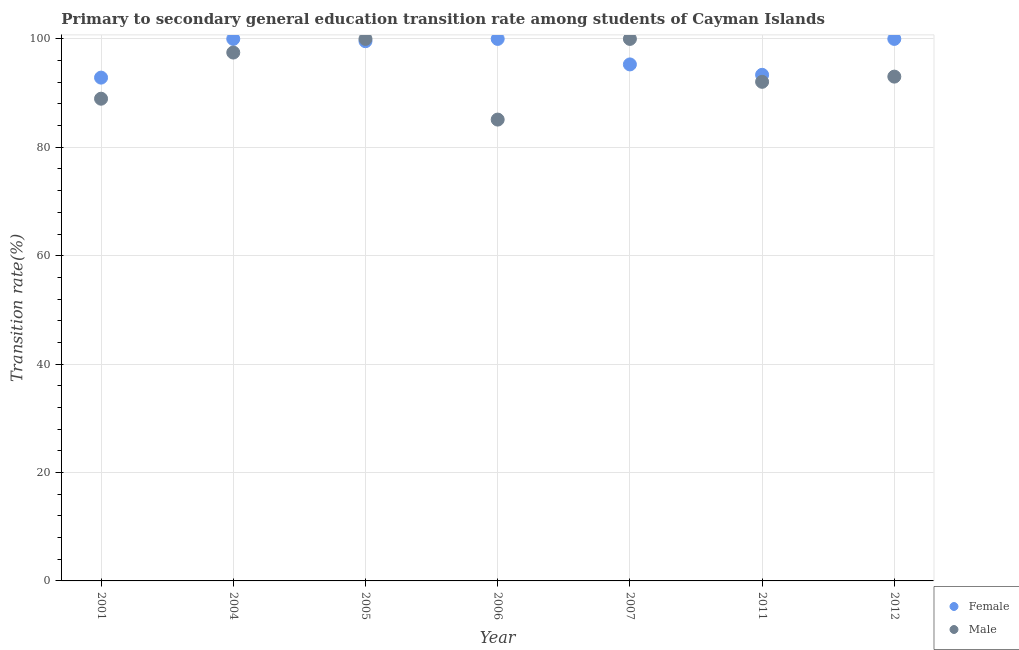What is the transition rate among male students in 2001?
Give a very brief answer. 88.97. Across all years, what is the minimum transition rate among male students?
Offer a very short reply. 85.12. In which year was the transition rate among male students maximum?
Provide a succinct answer. 2005. What is the total transition rate among female students in the graph?
Ensure brevity in your answer.  681.1. What is the difference between the transition rate among female students in 2001 and that in 2007?
Your response must be concise. -2.44. What is the difference between the transition rate among female students in 2006 and the transition rate among male students in 2004?
Make the answer very short. 2.52. What is the average transition rate among female students per year?
Offer a terse response. 97.3. In the year 2006, what is the difference between the transition rate among male students and transition rate among female students?
Keep it short and to the point. -14.88. In how many years, is the transition rate among male students greater than 84 %?
Your response must be concise. 7. What is the ratio of the transition rate among male students in 2006 to that in 2012?
Your response must be concise. 0.91. What is the difference between the highest and the second highest transition rate among male students?
Your response must be concise. 0. What is the difference between the highest and the lowest transition rate among male students?
Your answer should be compact. 14.88. In how many years, is the transition rate among female students greater than the average transition rate among female students taken over all years?
Your answer should be very brief. 4. Does the transition rate among male students monotonically increase over the years?
Provide a succinct answer. No. How many dotlines are there?
Your answer should be very brief. 2. How many years are there in the graph?
Your response must be concise. 7. Are the values on the major ticks of Y-axis written in scientific E-notation?
Make the answer very short. No. Does the graph contain any zero values?
Make the answer very short. No. Does the graph contain grids?
Provide a succinct answer. Yes. Where does the legend appear in the graph?
Give a very brief answer. Bottom right. What is the title of the graph?
Ensure brevity in your answer.  Primary to secondary general education transition rate among students of Cayman Islands. Does "Quasi money growth" appear as one of the legend labels in the graph?
Your answer should be very brief. No. What is the label or title of the X-axis?
Provide a short and direct response. Year. What is the label or title of the Y-axis?
Provide a short and direct response. Transition rate(%). What is the Transition rate(%) in Female in 2001?
Your response must be concise. 92.86. What is the Transition rate(%) of Male in 2001?
Your response must be concise. 88.97. What is the Transition rate(%) in Male in 2004?
Your answer should be very brief. 97.48. What is the Transition rate(%) of Female in 2005?
Your answer should be very brief. 99.58. What is the Transition rate(%) of Male in 2005?
Give a very brief answer. 100. What is the Transition rate(%) of Female in 2006?
Provide a short and direct response. 100. What is the Transition rate(%) in Male in 2006?
Keep it short and to the point. 85.12. What is the Transition rate(%) of Female in 2007?
Your answer should be compact. 95.29. What is the Transition rate(%) in Male in 2007?
Make the answer very short. 100. What is the Transition rate(%) of Female in 2011?
Provide a succinct answer. 93.37. What is the Transition rate(%) of Male in 2011?
Your response must be concise. 92.08. What is the Transition rate(%) of Female in 2012?
Your answer should be very brief. 100. What is the Transition rate(%) in Male in 2012?
Provide a short and direct response. 93.04. Across all years, what is the maximum Transition rate(%) in Male?
Give a very brief answer. 100. Across all years, what is the minimum Transition rate(%) in Female?
Provide a succinct answer. 92.86. Across all years, what is the minimum Transition rate(%) of Male?
Keep it short and to the point. 85.12. What is the total Transition rate(%) in Female in the graph?
Your answer should be very brief. 681.1. What is the total Transition rate(%) in Male in the graph?
Your answer should be very brief. 656.69. What is the difference between the Transition rate(%) of Female in 2001 and that in 2004?
Make the answer very short. -7.14. What is the difference between the Transition rate(%) in Male in 2001 and that in 2004?
Give a very brief answer. -8.52. What is the difference between the Transition rate(%) in Female in 2001 and that in 2005?
Provide a succinct answer. -6.72. What is the difference between the Transition rate(%) of Male in 2001 and that in 2005?
Ensure brevity in your answer.  -11.03. What is the difference between the Transition rate(%) in Female in 2001 and that in 2006?
Provide a short and direct response. -7.14. What is the difference between the Transition rate(%) in Male in 2001 and that in 2006?
Provide a short and direct response. 3.85. What is the difference between the Transition rate(%) of Female in 2001 and that in 2007?
Your answer should be compact. -2.44. What is the difference between the Transition rate(%) of Male in 2001 and that in 2007?
Give a very brief answer. -11.03. What is the difference between the Transition rate(%) of Female in 2001 and that in 2011?
Keep it short and to the point. -0.52. What is the difference between the Transition rate(%) of Male in 2001 and that in 2011?
Your response must be concise. -3.11. What is the difference between the Transition rate(%) in Female in 2001 and that in 2012?
Provide a short and direct response. -7.14. What is the difference between the Transition rate(%) of Male in 2001 and that in 2012?
Your answer should be compact. -4.07. What is the difference between the Transition rate(%) in Female in 2004 and that in 2005?
Your answer should be very brief. 0.42. What is the difference between the Transition rate(%) in Male in 2004 and that in 2005?
Offer a very short reply. -2.52. What is the difference between the Transition rate(%) of Female in 2004 and that in 2006?
Provide a succinct answer. 0. What is the difference between the Transition rate(%) of Male in 2004 and that in 2006?
Provide a succinct answer. 12.37. What is the difference between the Transition rate(%) of Female in 2004 and that in 2007?
Provide a succinct answer. 4.71. What is the difference between the Transition rate(%) in Male in 2004 and that in 2007?
Offer a very short reply. -2.52. What is the difference between the Transition rate(%) in Female in 2004 and that in 2011?
Offer a very short reply. 6.63. What is the difference between the Transition rate(%) of Male in 2004 and that in 2011?
Ensure brevity in your answer.  5.4. What is the difference between the Transition rate(%) of Female in 2004 and that in 2012?
Your response must be concise. 0. What is the difference between the Transition rate(%) in Male in 2004 and that in 2012?
Your answer should be very brief. 4.44. What is the difference between the Transition rate(%) in Female in 2005 and that in 2006?
Keep it short and to the point. -0.42. What is the difference between the Transition rate(%) in Male in 2005 and that in 2006?
Provide a short and direct response. 14.88. What is the difference between the Transition rate(%) of Female in 2005 and that in 2007?
Give a very brief answer. 4.28. What is the difference between the Transition rate(%) of Female in 2005 and that in 2011?
Your answer should be very brief. 6.2. What is the difference between the Transition rate(%) of Male in 2005 and that in 2011?
Your answer should be very brief. 7.92. What is the difference between the Transition rate(%) in Female in 2005 and that in 2012?
Offer a very short reply. -0.42. What is the difference between the Transition rate(%) in Male in 2005 and that in 2012?
Your response must be concise. 6.96. What is the difference between the Transition rate(%) in Female in 2006 and that in 2007?
Your answer should be compact. 4.71. What is the difference between the Transition rate(%) in Male in 2006 and that in 2007?
Give a very brief answer. -14.88. What is the difference between the Transition rate(%) in Female in 2006 and that in 2011?
Ensure brevity in your answer.  6.63. What is the difference between the Transition rate(%) of Male in 2006 and that in 2011?
Ensure brevity in your answer.  -6.97. What is the difference between the Transition rate(%) in Male in 2006 and that in 2012?
Give a very brief answer. -7.93. What is the difference between the Transition rate(%) of Female in 2007 and that in 2011?
Ensure brevity in your answer.  1.92. What is the difference between the Transition rate(%) in Male in 2007 and that in 2011?
Offer a very short reply. 7.92. What is the difference between the Transition rate(%) of Female in 2007 and that in 2012?
Your answer should be compact. -4.71. What is the difference between the Transition rate(%) in Male in 2007 and that in 2012?
Offer a terse response. 6.96. What is the difference between the Transition rate(%) of Female in 2011 and that in 2012?
Your response must be concise. -6.63. What is the difference between the Transition rate(%) of Male in 2011 and that in 2012?
Keep it short and to the point. -0.96. What is the difference between the Transition rate(%) in Female in 2001 and the Transition rate(%) in Male in 2004?
Give a very brief answer. -4.63. What is the difference between the Transition rate(%) in Female in 2001 and the Transition rate(%) in Male in 2005?
Your answer should be very brief. -7.14. What is the difference between the Transition rate(%) in Female in 2001 and the Transition rate(%) in Male in 2006?
Your answer should be very brief. 7.74. What is the difference between the Transition rate(%) of Female in 2001 and the Transition rate(%) of Male in 2007?
Your answer should be very brief. -7.14. What is the difference between the Transition rate(%) in Female in 2001 and the Transition rate(%) in Male in 2011?
Your answer should be very brief. 0.78. What is the difference between the Transition rate(%) in Female in 2001 and the Transition rate(%) in Male in 2012?
Keep it short and to the point. -0.18. What is the difference between the Transition rate(%) in Female in 2004 and the Transition rate(%) in Male in 2005?
Provide a succinct answer. 0. What is the difference between the Transition rate(%) in Female in 2004 and the Transition rate(%) in Male in 2006?
Your answer should be compact. 14.88. What is the difference between the Transition rate(%) in Female in 2004 and the Transition rate(%) in Male in 2011?
Your answer should be very brief. 7.92. What is the difference between the Transition rate(%) of Female in 2004 and the Transition rate(%) of Male in 2012?
Your response must be concise. 6.96. What is the difference between the Transition rate(%) in Female in 2005 and the Transition rate(%) in Male in 2006?
Provide a short and direct response. 14.46. What is the difference between the Transition rate(%) in Female in 2005 and the Transition rate(%) in Male in 2007?
Offer a terse response. -0.42. What is the difference between the Transition rate(%) in Female in 2005 and the Transition rate(%) in Male in 2011?
Offer a terse response. 7.5. What is the difference between the Transition rate(%) in Female in 2005 and the Transition rate(%) in Male in 2012?
Ensure brevity in your answer.  6.54. What is the difference between the Transition rate(%) in Female in 2006 and the Transition rate(%) in Male in 2007?
Your response must be concise. 0. What is the difference between the Transition rate(%) in Female in 2006 and the Transition rate(%) in Male in 2011?
Your answer should be compact. 7.92. What is the difference between the Transition rate(%) of Female in 2006 and the Transition rate(%) of Male in 2012?
Keep it short and to the point. 6.96. What is the difference between the Transition rate(%) in Female in 2007 and the Transition rate(%) in Male in 2011?
Provide a short and direct response. 3.21. What is the difference between the Transition rate(%) in Female in 2007 and the Transition rate(%) in Male in 2012?
Provide a succinct answer. 2.25. What is the difference between the Transition rate(%) of Female in 2011 and the Transition rate(%) of Male in 2012?
Your answer should be compact. 0.33. What is the average Transition rate(%) of Female per year?
Your answer should be very brief. 97.3. What is the average Transition rate(%) of Male per year?
Offer a terse response. 93.81. In the year 2001, what is the difference between the Transition rate(%) in Female and Transition rate(%) in Male?
Your response must be concise. 3.89. In the year 2004, what is the difference between the Transition rate(%) in Female and Transition rate(%) in Male?
Keep it short and to the point. 2.52. In the year 2005, what is the difference between the Transition rate(%) in Female and Transition rate(%) in Male?
Your answer should be very brief. -0.42. In the year 2006, what is the difference between the Transition rate(%) in Female and Transition rate(%) in Male?
Your answer should be very brief. 14.88. In the year 2007, what is the difference between the Transition rate(%) in Female and Transition rate(%) in Male?
Ensure brevity in your answer.  -4.71. In the year 2011, what is the difference between the Transition rate(%) of Female and Transition rate(%) of Male?
Offer a very short reply. 1.29. In the year 2012, what is the difference between the Transition rate(%) of Female and Transition rate(%) of Male?
Your answer should be compact. 6.96. What is the ratio of the Transition rate(%) in Male in 2001 to that in 2004?
Your response must be concise. 0.91. What is the ratio of the Transition rate(%) in Female in 2001 to that in 2005?
Ensure brevity in your answer.  0.93. What is the ratio of the Transition rate(%) in Male in 2001 to that in 2005?
Your answer should be very brief. 0.89. What is the ratio of the Transition rate(%) in Female in 2001 to that in 2006?
Your response must be concise. 0.93. What is the ratio of the Transition rate(%) of Male in 2001 to that in 2006?
Your answer should be compact. 1.05. What is the ratio of the Transition rate(%) of Female in 2001 to that in 2007?
Provide a short and direct response. 0.97. What is the ratio of the Transition rate(%) in Male in 2001 to that in 2007?
Offer a terse response. 0.89. What is the ratio of the Transition rate(%) in Female in 2001 to that in 2011?
Your answer should be compact. 0.99. What is the ratio of the Transition rate(%) in Male in 2001 to that in 2011?
Your answer should be compact. 0.97. What is the ratio of the Transition rate(%) of Male in 2001 to that in 2012?
Offer a terse response. 0.96. What is the ratio of the Transition rate(%) in Female in 2004 to that in 2005?
Offer a very short reply. 1. What is the ratio of the Transition rate(%) in Male in 2004 to that in 2005?
Give a very brief answer. 0.97. What is the ratio of the Transition rate(%) in Male in 2004 to that in 2006?
Ensure brevity in your answer.  1.15. What is the ratio of the Transition rate(%) in Female in 2004 to that in 2007?
Ensure brevity in your answer.  1.05. What is the ratio of the Transition rate(%) of Male in 2004 to that in 2007?
Offer a very short reply. 0.97. What is the ratio of the Transition rate(%) of Female in 2004 to that in 2011?
Provide a short and direct response. 1.07. What is the ratio of the Transition rate(%) in Male in 2004 to that in 2011?
Keep it short and to the point. 1.06. What is the ratio of the Transition rate(%) in Male in 2004 to that in 2012?
Provide a succinct answer. 1.05. What is the ratio of the Transition rate(%) in Male in 2005 to that in 2006?
Give a very brief answer. 1.17. What is the ratio of the Transition rate(%) of Female in 2005 to that in 2007?
Your answer should be compact. 1.04. What is the ratio of the Transition rate(%) of Male in 2005 to that in 2007?
Provide a succinct answer. 1. What is the ratio of the Transition rate(%) in Female in 2005 to that in 2011?
Make the answer very short. 1.07. What is the ratio of the Transition rate(%) of Male in 2005 to that in 2011?
Give a very brief answer. 1.09. What is the ratio of the Transition rate(%) of Male in 2005 to that in 2012?
Your response must be concise. 1.07. What is the ratio of the Transition rate(%) in Female in 2006 to that in 2007?
Offer a terse response. 1.05. What is the ratio of the Transition rate(%) in Male in 2006 to that in 2007?
Ensure brevity in your answer.  0.85. What is the ratio of the Transition rate(%) of Female in 2006 to that in 2011?
Your answer should be very brief. 1.07. What is the ratio of the Transition rate(%) of Male in 2006 to that in 2011?
Make the answer very short. 0.92. What is the ratio of the Transition rate(%) of Male in 2006 to that in 2012?
Your response must be concise. 0.91. What is the ratio of the Transition rate(%) of Female in 2007 to that in 2011?
Provide a short and direct response. 1.02. What is the ratio of the Transition rate(%) of Male in 2007 to that in 2011?
Keep it short and to the point. 1.09. What is the ratio of the Transition rate(%) of Female in 2007 to that in 2012?
Your response must be concise. 0.95. What is the ratio of the Transition rate(%) of Male in 2007 to that in 2012?
Your answer should be compact. 1.07. What is the ratio of the Transition rate(%) in Female in 2011 to that in 2012?
Provide a succinct answer. 0.93. What is the difference between the highest and the second highest Transition rate(%) in Female?
Offer a terse response. 0. What is the difference between the highest and the second highest Transition rate(%) of Male?
Offer a very short reply. 0. What is the difference between the highest and the lowest Transition rate(%) of Female?
Your answer should be very brief. 7.14. What is the difference between the highest and the lowest Transition rate(%) in Male?
Provide a short and direct response. 14.88. 